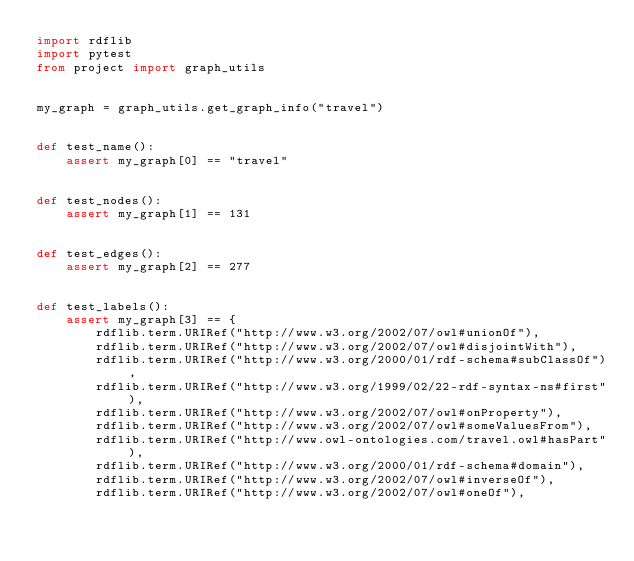<code> <loc_0><loc_0><loc_500><loc_500><_Python_>import rdflib
import pytest
from project import graph_utils


my_graph = graph_utils.get_graph_info("travel")


def test_name():
    assert my_graph[0] == "travel"


def test_nodes():
    assert my_graph[1] == 131


def test_edges():
    assert my_graph[2] == 277


def test_labels():
    assert my_graph[3] == {
        rdflib.term.URIRef("http://www.w3.org/2002/07/owl#unionOf"),
        rdflib.term.URIRef("http://www.w3.org/2002/07/owl#disjointWith"),
        rdflib.term.URIRef("http://www.w3.org/2000/01/rdf-schema#subClassOf"),
        rdflib.term.URIRef("http://www.w3.org/1999/02/22-rdf-syntax-ns#first"),
        rdflib.term.URIRef("http://www.w3.org/2002/07/owl#onProperty"),
        rdflib.term.URIRef("http://www.w3.org/2002/07/owl#someValuesFrom"),
        rdflib.term.URIRef("http://www.owl-ontologies.com/travel.owl#hasPart"),
        rdflib.term.URIRef("http://www.w3.org/2000/01/rdf-schema#domain"),
        rdflib.term.URIRef("http://www.w3.org/2002/07/owl#inverseOf"),
        rdflib.term.URIRef("http://www.w3.org/2002/07/owl#oneOf"),</code> 